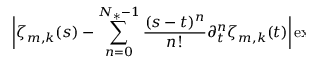Convert formula to latex. <formula><loc_0><loc_0><loc_500><loc_500>\begin{array} { r l } { { \left | \zeta _ { m , k } ( s ) - \sum _ { n = 0 } ^ { N _ { * } - 1 } \frac { ( s - t ) ^ { n } } { n ! } \partial _ { t } ^ { n } \zeta _ { m , k } ( t ) \right | \exp \left ( \frac { 4 \pi ^ { 2 } \kappa } { \varepsilon _ { m } ^ { 2 } } ( s - t ) \right ) \, d s } \quad } \end{array}</formula> 